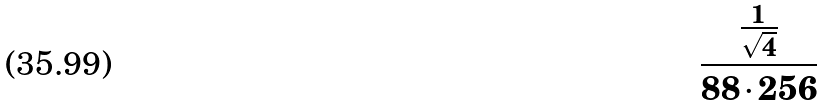Convert formula to latex. <formula><loc_0><loc_0><loc_500><loc_500>\frac { \frac { 1 } { \sqrt { 4 } } } { 8 8 \cdot 2 5 6 }</formula> 